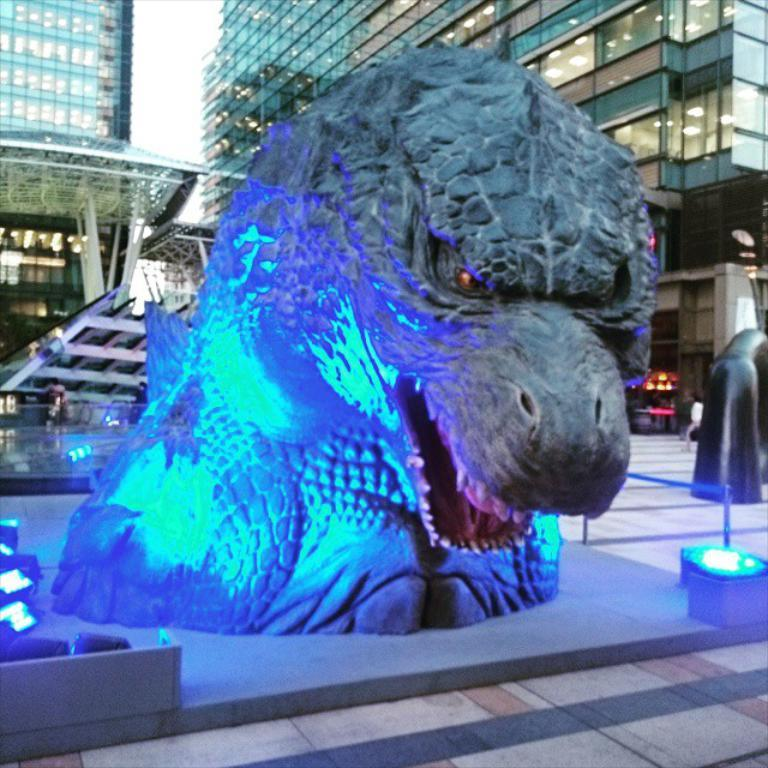What is the main subject of the image? There is a sculpture in the image. What can be seen in the distance behind the sculpture? There are buildings in the background of the image. Are there any additional elements visible in the image? Yes, there are lights visible in the image. Can you tell me how many wishes the sculpture can grant in the image? The sculpture in the image is not a magical entity, so it cannot grant wishes. 